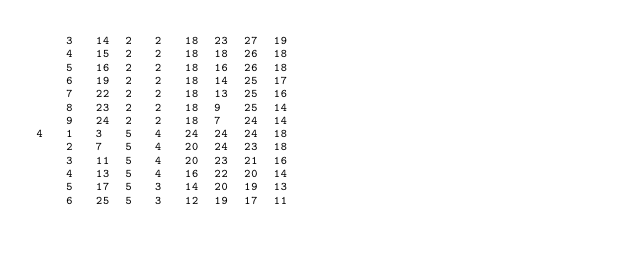<code> <loc_0><loc_0><loc_500><loc_500><_ObjectiveC_>	3	14	2	2	18	23	27	19	
	4	15	2	2	18	18	26	18	
	5	16	2	2	18	16	26	18	
	6	19	2	2	18	14	25	17	
	7	22	2	2	18	13	25	16	
	8	23	2	2	18	9	25	14	
	9	24	2	2	18	7	24	14	
4	1	3	5	4	24	24	24	18	
	2	7	5	4	20	24	23	18	
	3	11	5	4	20	23	21	16	
	4	13	5	4	16	22	20	14	
	5	17	5	3	14	20	19	13	
	6	25	5	3	12	19	17	11	</code> 